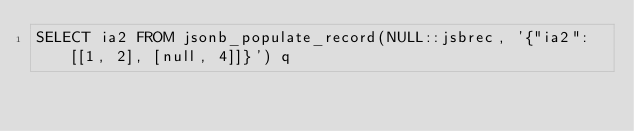<code> <loc_0><loc_0><loc_500><loc_500><_SQL_>SELECT ia2 FROM jsonb_populate_record(NULL::jsbrec, '{"ia2": [[1, 2], [null, 4]]}') q
</code> 